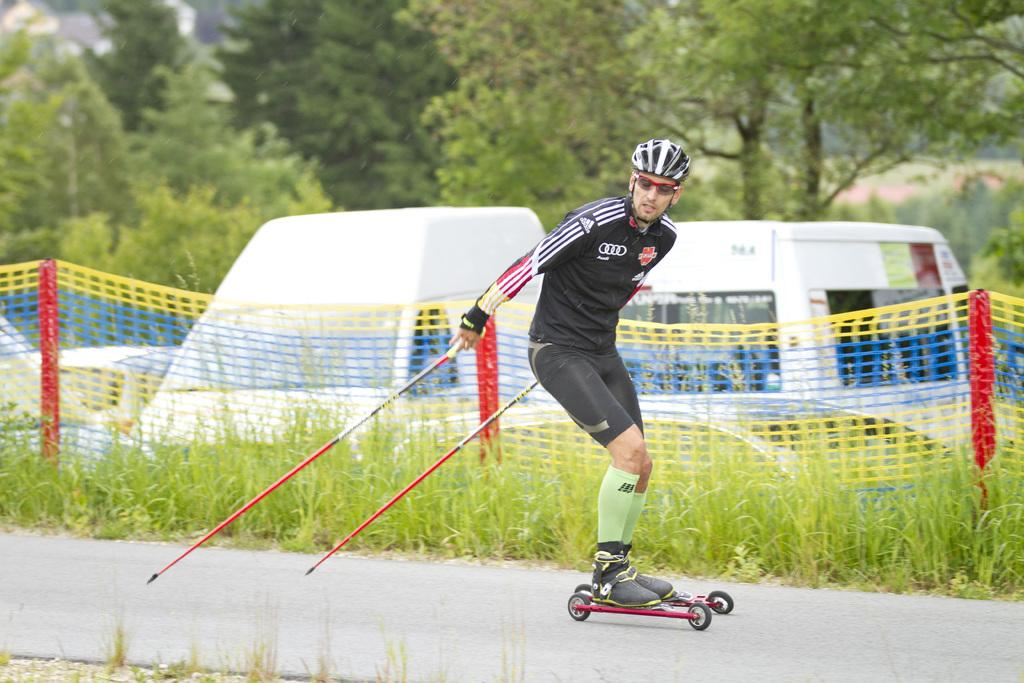What is the person in the image doing? There is a person skating in the image. On what surface is the person skating? The person is skating on the road. What can be seen in the background of the image? There is grass, nets, vehicles, and trees in the background of the image. How many boys wearing skirts are visible in the image? There are no boys or skirts present in the image. What type of loaf is being used by the person skating in the image? There is no loaf present in the image; the person is skating on the road. 